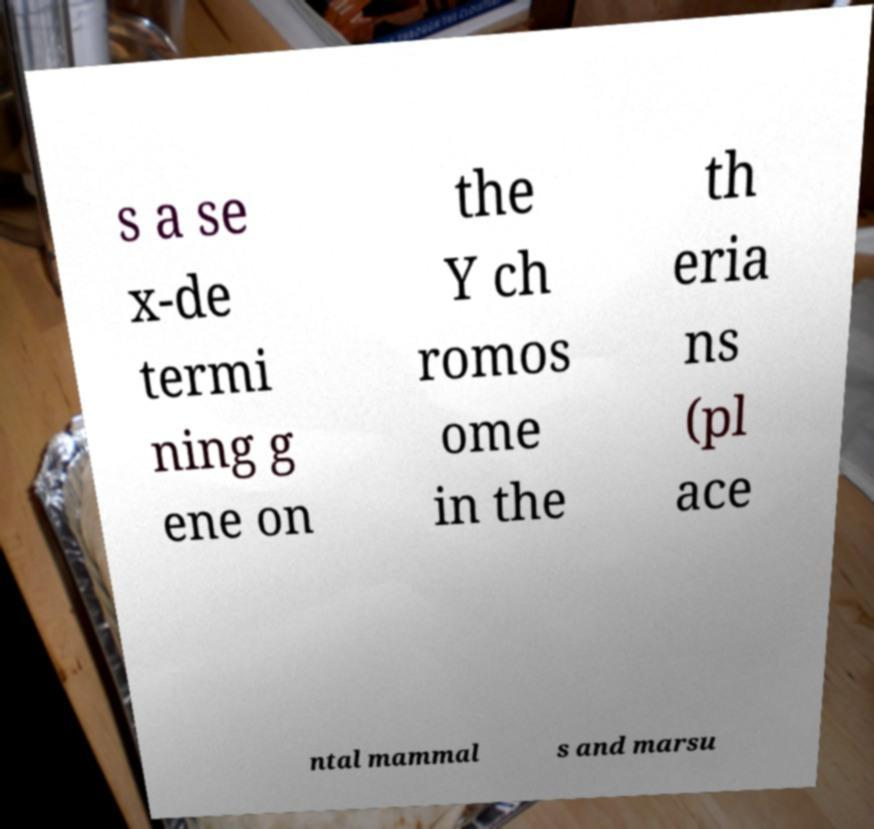Could you assist in decoding the text presented in this image and type it out clearly? s a se x-de termi ning g ene on the Y ch romos ome in the th eria ns (pl ace ntal mammal s and marsu 